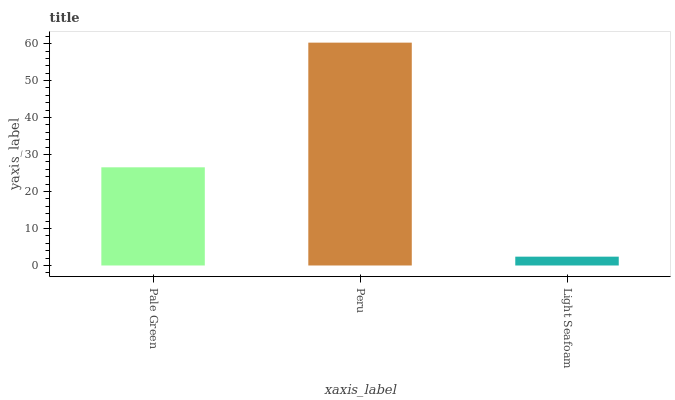Is Light Seafoam the minimum?
Answer yes or no. Yes. Is Peru the maximum?
Answer yes or no. Yes. Is Peru the minimum?
Answer yes or no. No. Is Light Seafoam the maximum?
Answer yes or no. No. Is Peru greater than Light Seafoam?
Answer yes or no. Yes. Is Light Seafoam less than Peru?
Answer yes or no. Yes. Is Light Seafoam greater than Peru?
Answer yes or no. No. Is Peru less than Light Seafoam?
Answer yes or no. No. Is Pale Green the high median?
Answer yes or no. Yes. Is Pale Green the low median?
Answer yes or no. Yes. Is Peru the high median?
Answer yes or no. No. Is Light Seafoam the low median?
Answer yes or no. No. 